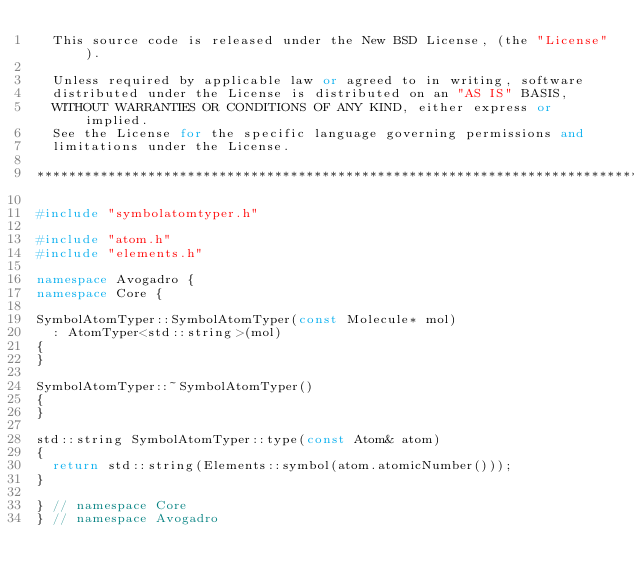<code> <loc_0><loc_0><loc_500><loc_500><_C++_>  This source code is released under the New BSD License, (the "License").

  Unless required by applicable law or agreed to in writing, software
  distributed under the License is distributed on an "AS IS" BASIS,
  WITHOUT WARRANTIES OR CONDITIONS OF ANY KIND, either express or implied.
  See the License for the specific language governing permissions and
  limitations under the License.

******************************************************************************/

#include "symbolatomtyper.h"

#include "atom.h"
#include "elements.h"

namespace Avogadro {
namespace Core {

SymbolAtomTyper::SymbolAtomTyper(const Molecule* mol)
  : AtomTyper<std::string>(mol)
{
}

SymbolAtomTyper::~SymbolAtomTyper()
{
}

std::string SymbolAtomTyper::type(const Atom& atom)
{
  return std::string(Elements::symbol(atom.atomicNumber()));
}

} // namespace Core
} // namespace Avogadro
</code> 